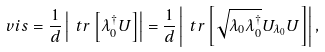<formula> <loc_0><loc_0><loc_500><loc_500>\ v i s = \frac { 1 } { d } \left | \ t r \left [ \lambda _ { 0 } ^ { \dagger } U \right ] \right | = \frac { 1 } { d } \left | \ t r \left [ \sqrt { \lambda _ { 0 } \lambda _ { 0 } ^ { \dagger } } U _ { \lambda _ { 0 } } U \right ] \right | ,</formula> 